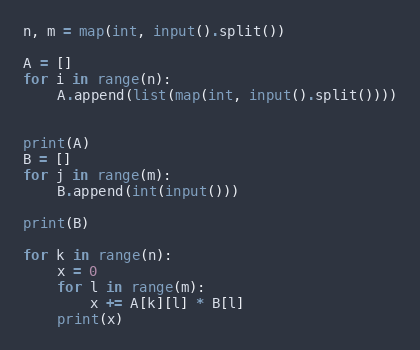<code> <loc_0><loc_0><loc_500><loc_500><_Python_>n, m = map(int, input().split())

A = []
for i in range(n):
    A.append(list(map(int, input().split())))


print(A)
B = []
for j in range(m):
    B.append(int(input()))

print(B)

for k in range(n):
    x = 0
    for l in range(m):
        x += A[k][l] * B[l]
    print(x)</code> 